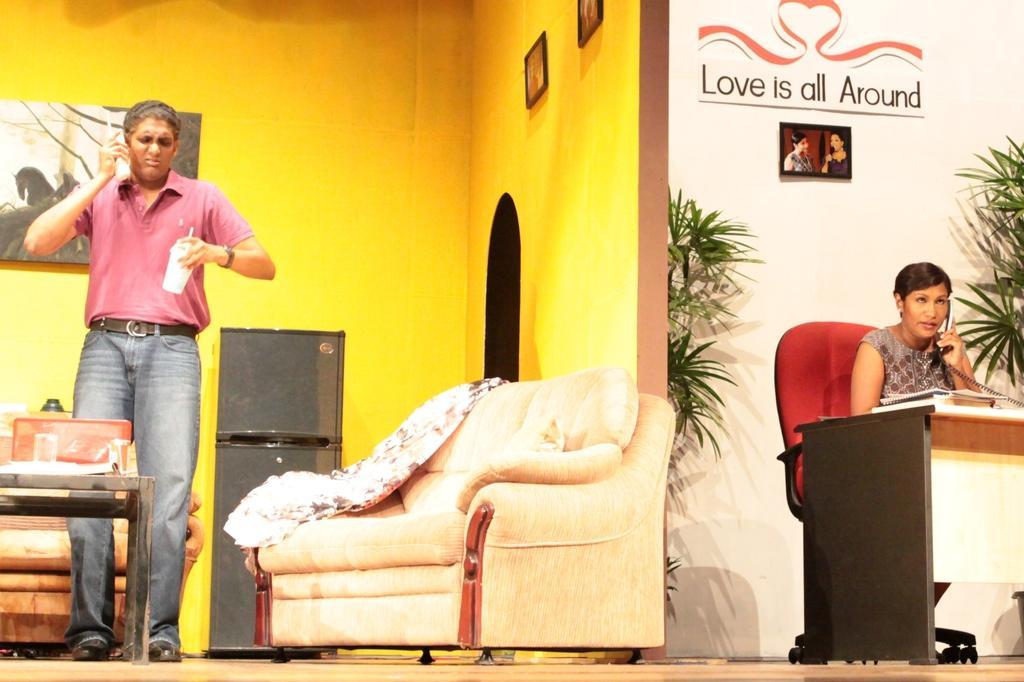Can you describe this image briefly? In this image I can see a man standing on the left. He is holding a telephone. There is a table in front him. There is a refrigerator behind him and there are sofas. A woman is sitting on the right and holding a telephone. There is a table in front of her and there are plants behind her. There are photo frames on the walls. 